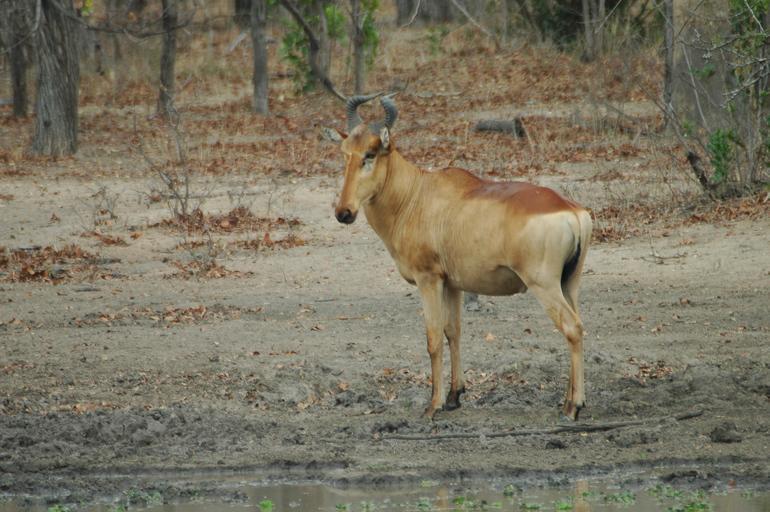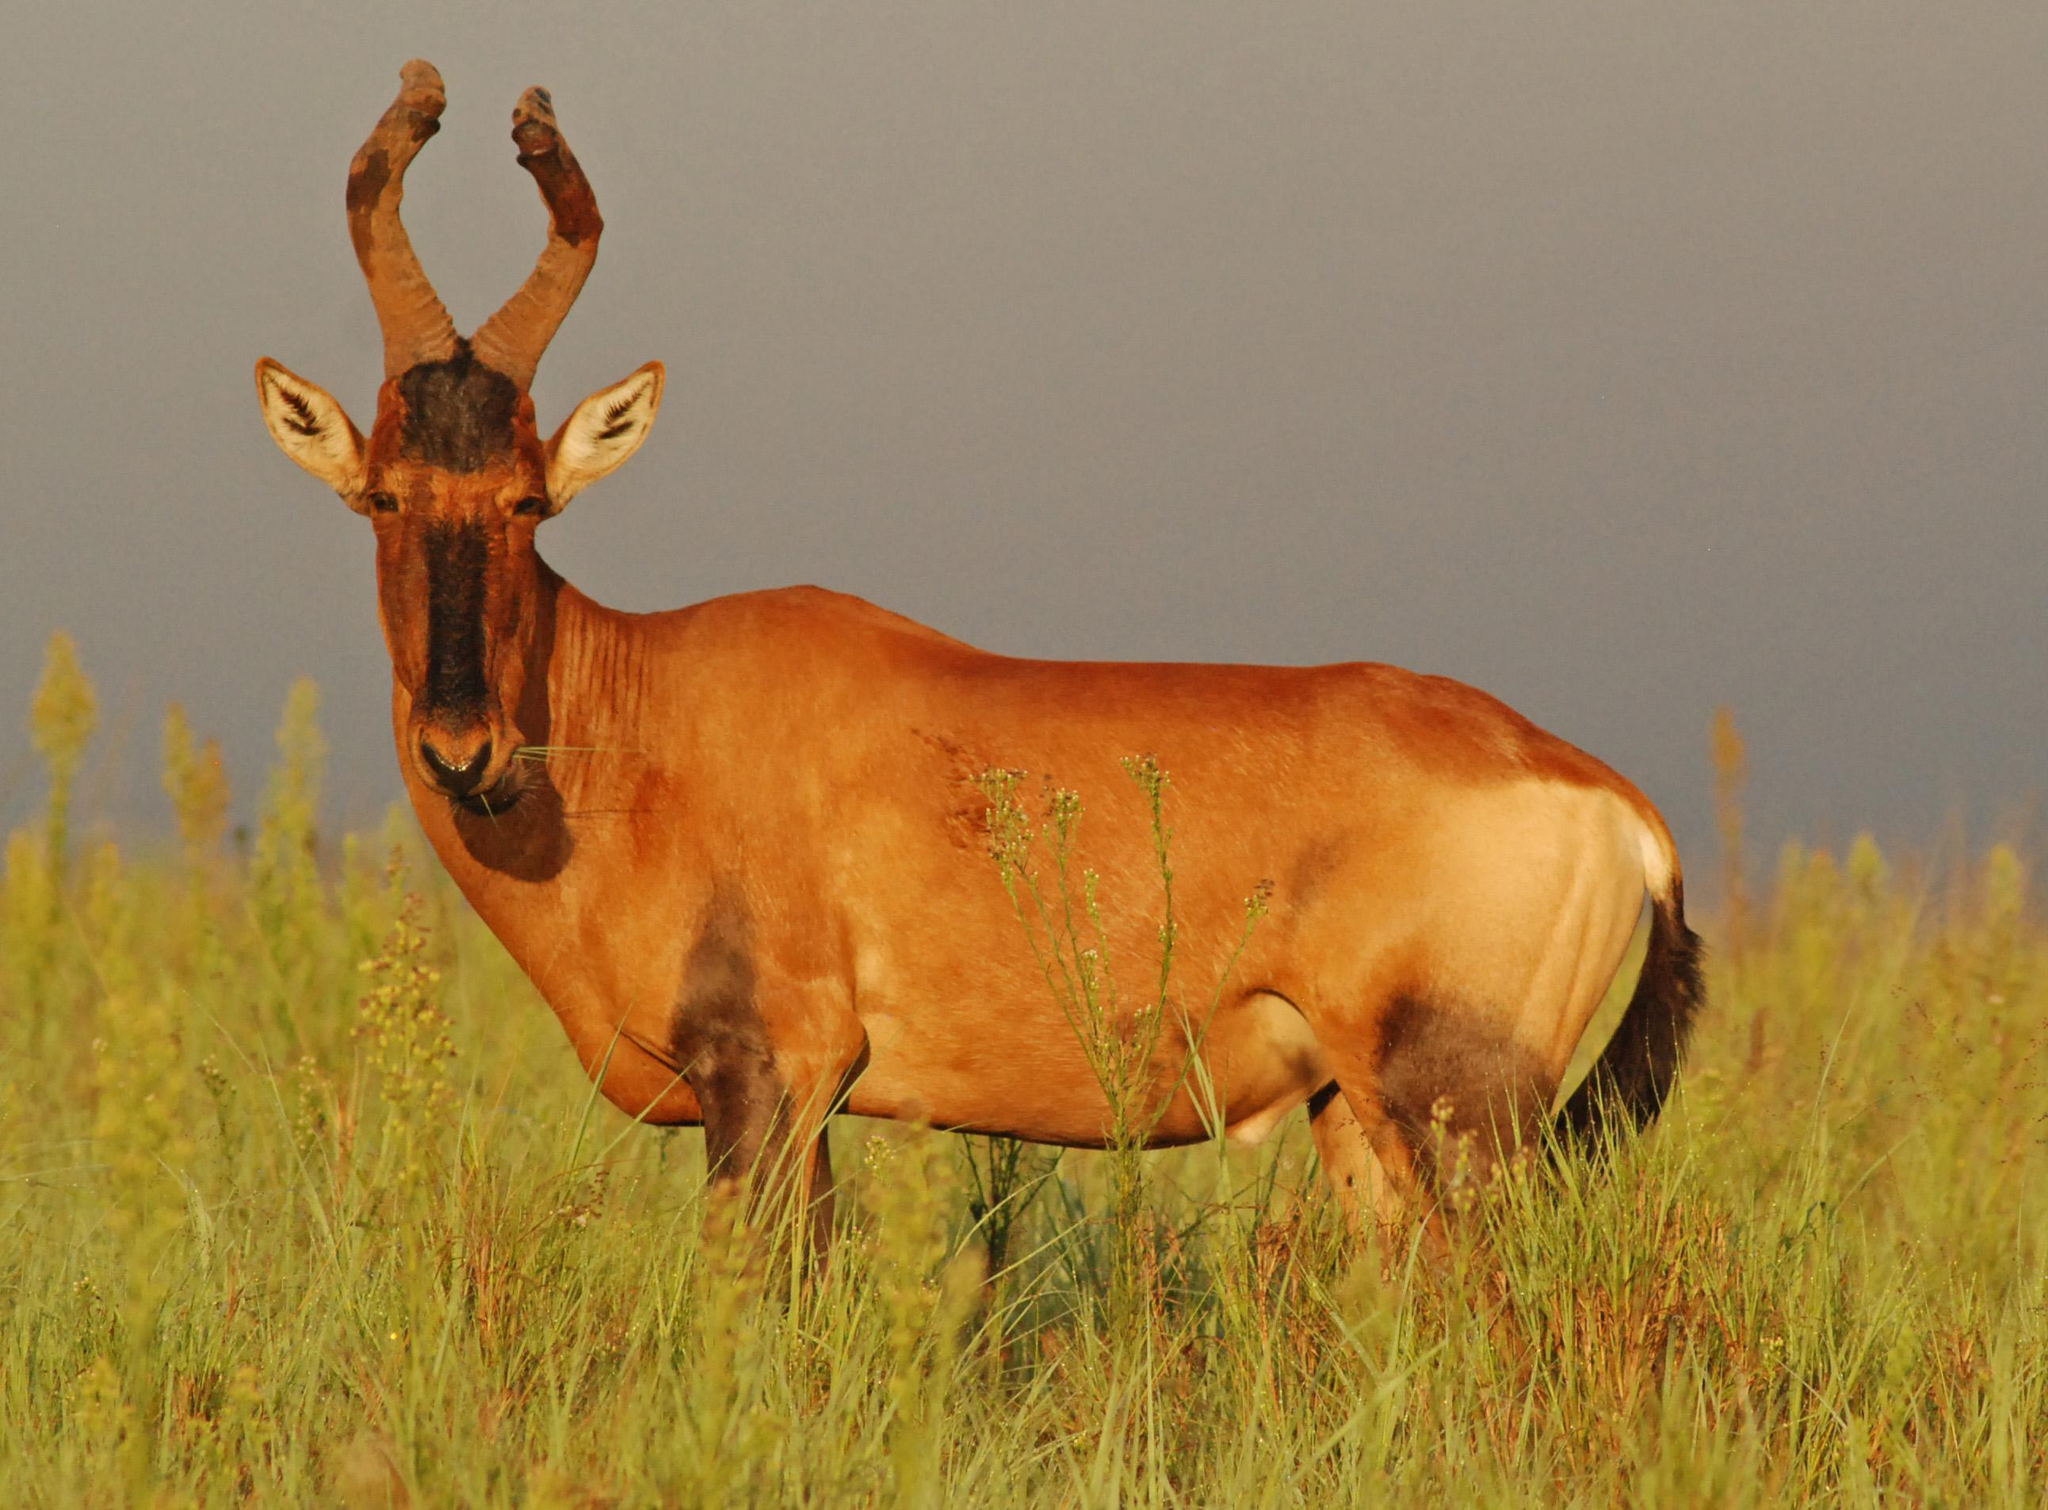The first image is the image on the left, the second image is the image on the right. For the images displayed, is the sentence "All animals are oriented/facing the same direction." factually correct? Answer yes or no. Yes. The first image is the image on the left, the second image is the image on the right. Given the left and right images, does the statement "Each image contains one horned animal, and the animals on the left and right have their bodies turned in the same general direction." hold true? Answer yes or no. Yes. 